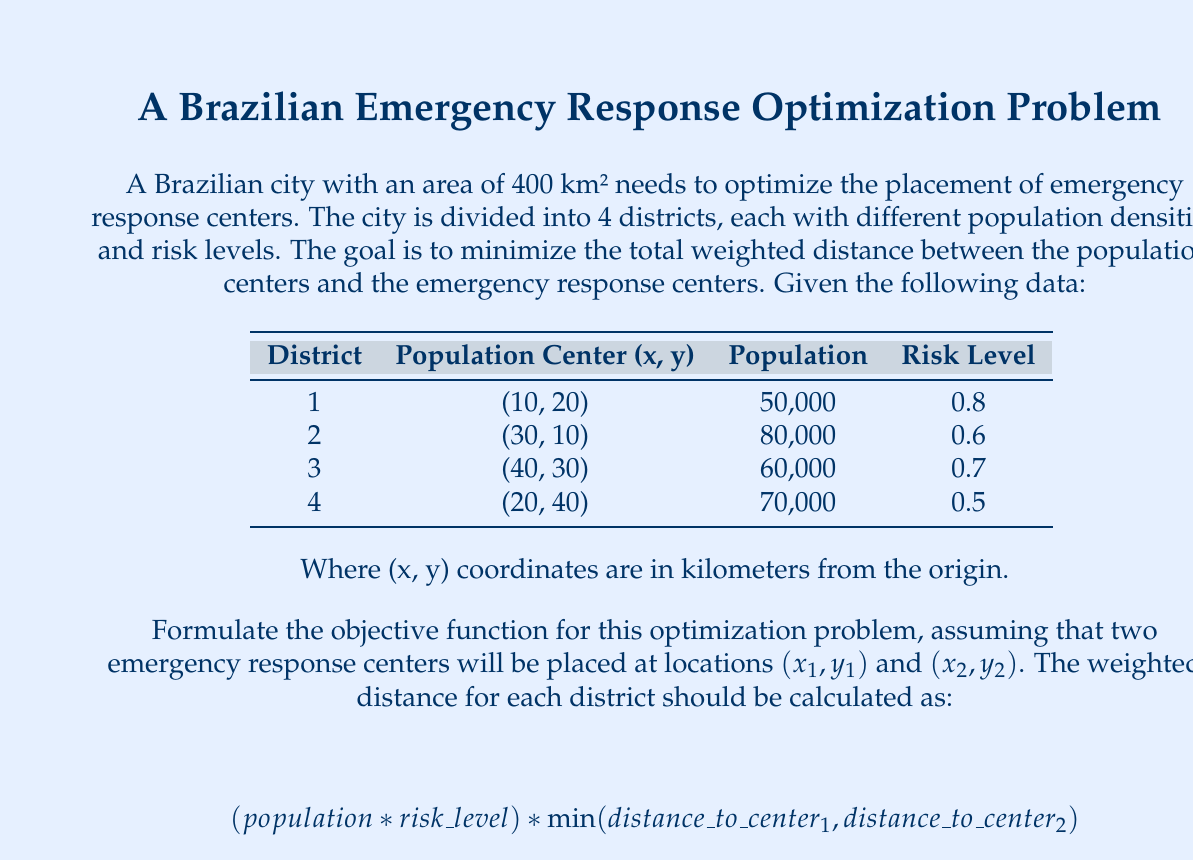What is the answer to this math problem? To formulate the objective function, we need to follow these steps:

1. Define variables:
   $(x_1, y_1)$: coordinates of the first emergency response center
   $(x_2, y_2)$: coordinates of the second emergency response center

2. Calculate the distance from each population center to both emergency response centers using the Euclidean distance formula:
   $$d = \sqrt{(x_2 - x_1)^2 + (y_2 - y_1)^2}$$

3. For each district, calculate the weighted distance to the nearest center:
   $$w_i = (population_i * risk\_level_i) * min(\sqrt{(x_1 - x_i)^2 + (y_1 - y_i)^2}, \sqrt{(x_2 - x_i)^2 + (y_2 - y_i)^2})$$
   Where $(x_i, y_i)$ are the coordinates of the population center for district $i$.

4. Sum up the weighted distances for all districts to get the objective function:
   $$minimize \sum_{i=1}^{4} w_i$$

Now, let's calculate the weights for each district:
District 1: $50,000 * 0.8 = 40,000$
District 2: $80,000 * 0.6 = 48,000$
District 3: $60,000 * 0.7 = 42,000$
District 4: $70,000 * 0.5 = 35,000$

Putting it all together, we get the following objective function:

$$minimize \left[ \begin{aligned}
& 40,000 * min(\sqrt{(x_1 - 10)^2 + (y_1 - 20)^2}, \sqrt{(x_2 - 10)^2 + (y_2 - 20)^2}) + \\
& 48,000 * min(\sqrt{(x_1 - 30)^2 + (y_1 - 10)^2}, \sqrt{(x_2 - 30)^2 + (y_2 - 10)^2}) + \\
& 42,000 * min(\sqrt{(x_1 - 40)^2 + (y_1 - 30)^2}, \sqrt{(x_2 - 40)^2 + (y_2 - 30)^2}) + \\
& 35,000 * min(\sqrt{(x_1 - 20)^2 + (y_1 - 40)^2}, \sqrt{(x_2 - 20)^2 + (y_2 - 40)^2})
\end{aligned} \right]$$

This objective function represents the total weighted distance that needs to be minimized by choosing optimal values for $x_1, y_1, x_2,$ and $y_2$.
Answer: The objective function for optimizing the placement of two emergency response centers is:

$$minimize \left[ \begin{aligned}
& 40,000 * min(\sqrt{(x_1 - 10)^2 + (y_1 - 20)^2}, \sqrt{(x_2 - 10)^2 + (y_2 - 20)^2}) + \\
& 48,000 * min(\sqrt{(x_1 - 30)^2 + (y_1 - 10)^2}, \sqrt{(x_2 - 30)^2 + (y_2 - 10)^2}) + \\
& 42,000 * min(\sqrt{(x_1 - 40)^2 + (y_1 - 30)^2}, \sqrt{(x_2 - 40)^2 + (y_2 - 30)^2}) + \\
& 35,000 * min(\sqrt{(x_1 - 20)^2 + (y_1 - 40)^2}, \sqrt{(x_2 - 20)^2 + (y_2 - 40)^2})
\end{aligned} \right]$$

Where $(x_1, y_1)$ and $(x_2, y_2)$ are the coordinates of the two emergency response centers to be determined. 